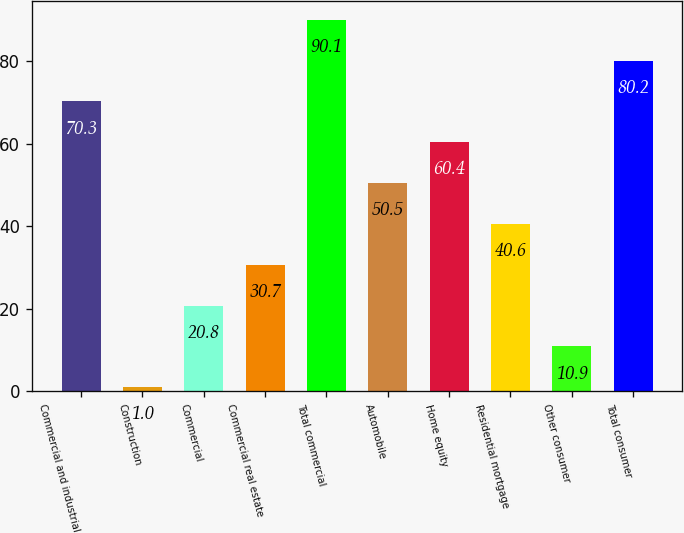Convert chart to OTSL. <chart><loc_0><loc_0><loc_500><loc_500><bar_chart><fcel>Commercial and industrial<fcel>Construction<fcel>Commercial<fcel>Commercial real estate<fcel>Total commercial<fcel>Automobile<fcel>Home equity<fcel>Residential mortgage<fcel>Other consumer<fcel>Total consumer<nl><fcel>70.3<fcel>1<fcel>20.8<fcel>30.7<fcel>90.1<fcel>50.5<fcel>60.4<fcel>40.6<fcel>10.9<fcel>80.2<nl></chart> 